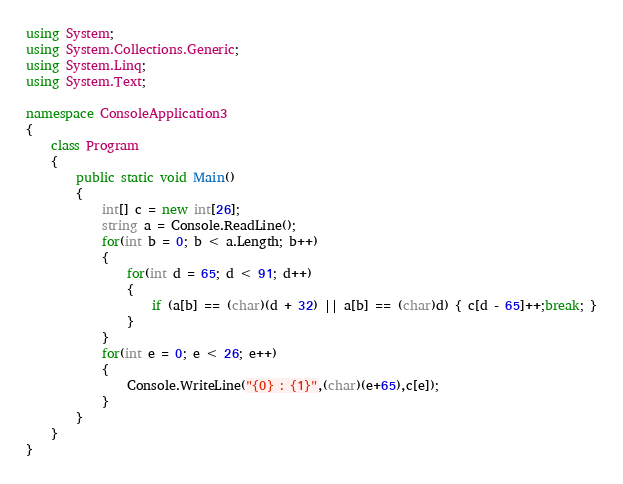<code> <loc_0><loc_0><loc_500><loc_500><_C#_>using System;
using System.Collections.Generic;
using System.Linq;
using System.Text;

namespace ConsoleApplication3
{
    class Program
    {
        public static void Main()
        {
            int[] c = new int[26];
            string a = Console.ReadLine();
            for(int b = 0; b < a.Length; b++)
            {
                for(int d = 65; d < 91; d++)
                {
                    if (a[b] == (char)(d + 32) || a[b] == (char)d) { c[d - 65]++;break; }
                }
            }
            for(int e = 0; e < 26; e++)
            {
                Console.WriteLine("{0} : {1}",(char)(e+65),c[e]);
            }
        }
    }
}</code> 